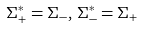Convert formula to latex. <formula><loc_0><loc_0><loc_500><loc_500>\Sigma _ { + } ^ { * } = \Sigma _ { - } , \, \Sigma _ { - } ^ { * } = \Sigma _ { + }</formula> 